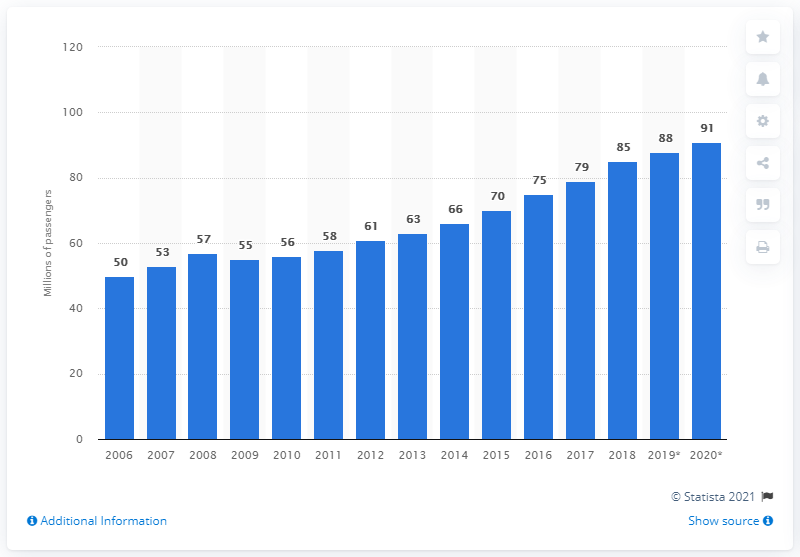Specify some key components in this picture. In 2019, a total of 88,000 passengers traveled to or from the United States via the Atlantic route. 